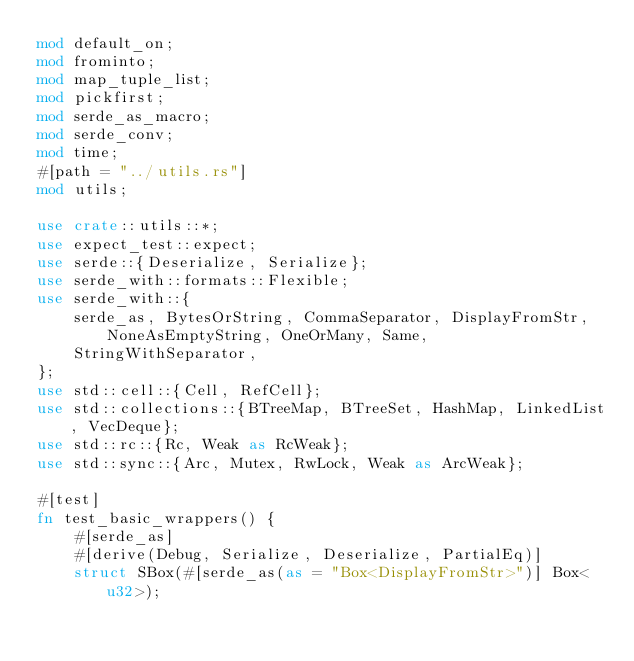<code> <loc_0><loc_0><loc_500><loc_500><_Rust_>mod default_on;
mod frominto;
mod map_tuple_list;
mod pickfirst;
mod serde_as_macro;
mod serde_conv;
mod time;
#[path = "../utils.rs"]
mod utils;

use crate::utils::*;
use expect_test::expect;
use serde::{Deserialize, Serialize};
use serde_with::formats::Flexible;
use serde_with::{
    serde_as, BytesOrString, CommaSeparator, DisplayFromStr, NoneAsEmptyString, OneOrMany, Same,
    StringWithSeparator,
};
use std::cell::{Cell, RefCell};
use std::collections::{BTreeMap, BTreeSet, HashMap, LinkedList, VecDeque};
use std::rc::{Rc, Weak as RcWeak};
use std::sync::{Arc, Mutex, RwLock, Weak as ArcWeak};

#[test]
fn test_basic_wrappers() {
    #[serde_as]
    #[derive(Debug, Serialize, Deserialize, PartialEq)]
    struct SBox(#[serde_as(as = "Box<DisplayFromStr>")] Box<u32>);
</code> 